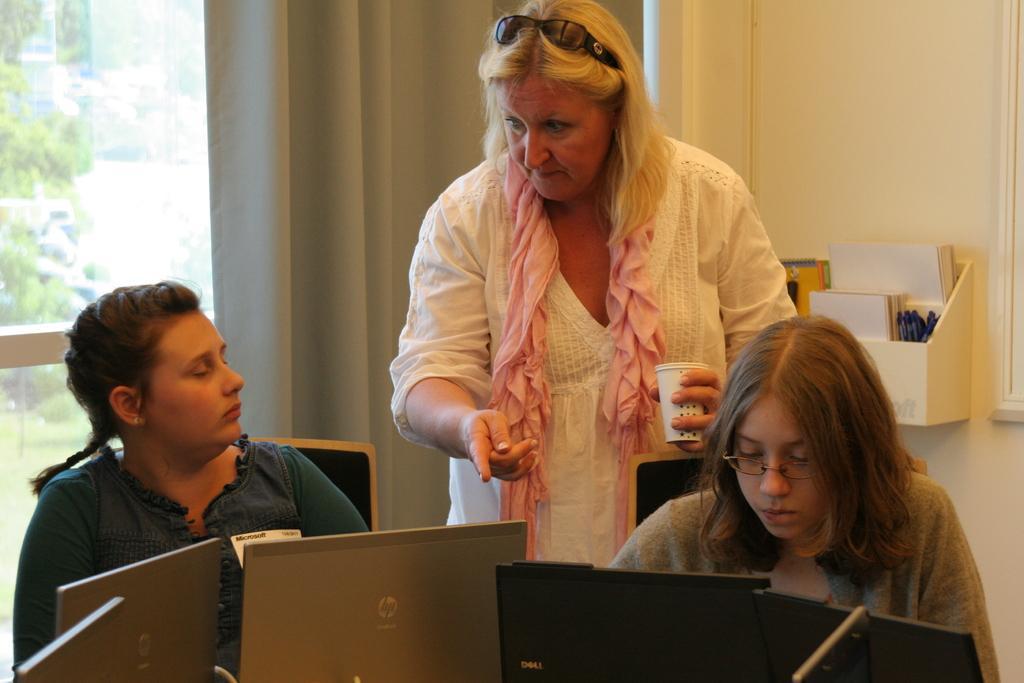Describe this image in one or two sentences. In this image I can see two people sitting and one person is standing and holding a cup. I can see few laptops. Back I can see glass windows,curtain and books rack attached to the wall. 